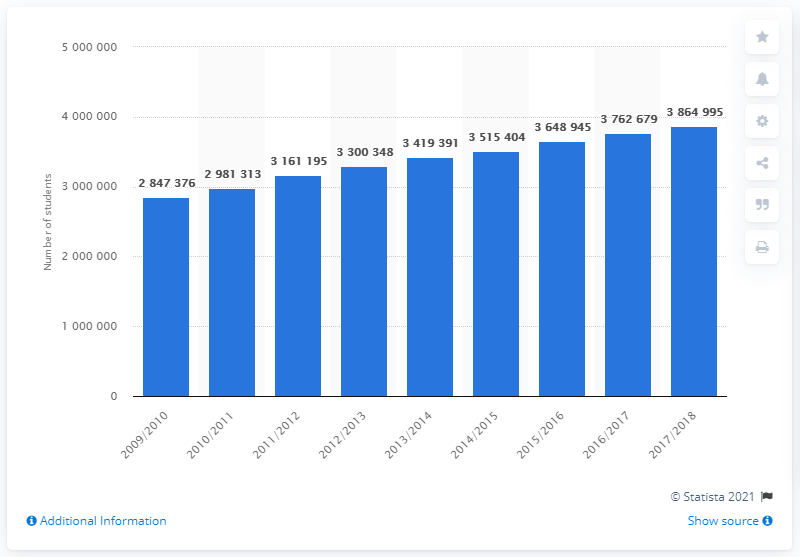Outline some significant characteristics in this image. In the 2017/2018 academic year, a total of 3864,995 students were enrolled in formal higher education programs in Mexico. 